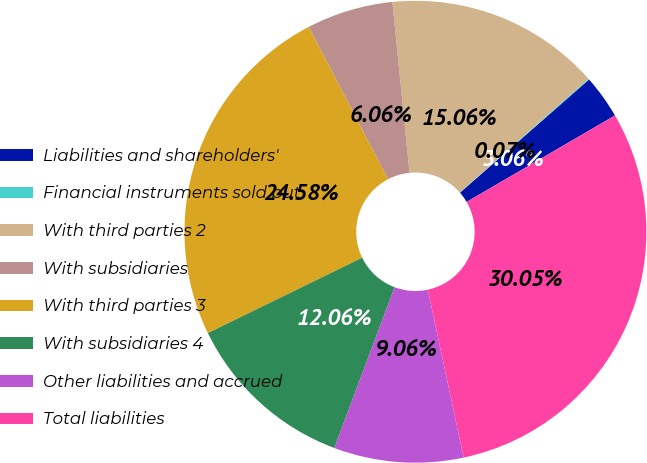Convert chart to OTSL. <chart><loc_0><loc_0><loc_500><loc_500><pie_chart><fcel>Liabilities and shareholders'<fcel>Financial instruments sold but<fcel>With third parties 2<fcel>With subsidiaries<fcel>With third parties 3<fcel>With subsidiaries 4<fcel>Other liabilities and accrued<fcel>Total liabilities<nl><fcel>3.06%<fcel>0.07%<fcel>15.06%<fcel>6.06%<fcel>24.58%<fcel>12.06%<fcel>9.06%<fcel>30.05%<nl></chart> 